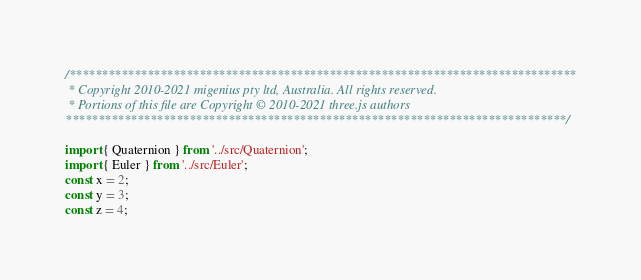<code> <loc_0><loc_0><loc_500><loc_500><_JavaScript_>/******************************************************************************
 * Copyright 2010-2021 migenius pty ltd, Australia. All rights reserved.
 * Portions of this file are Copyright © 2010-2021 three.js authors
*****************************************************************************/

import { Quaternion } from '../src/Quaternion';
import { Euler } from '../src/Euler';
const x = 2;
const y = 3;
const z = 4;</code> 